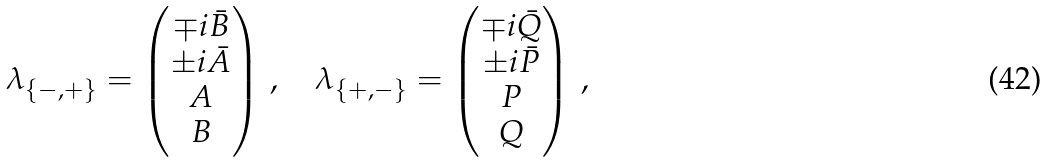Convert formula to latex. <formula><loc_0><loc_0><loc_500><loc_500>\lambda _ { \{ - , + \} } = \begin{pmatrix} \mp i \bar { B } \\ \pm i \bar { A } \\ A \\ B \end{pmatrix} \, , \quad \lambda _ { \{ + , - \} } = \begin{pmatrix} \mp i \bar { Q } \\ \pm i \bar { P } \\ P \\ Q \end{pmatrix} \, ,</formula> 